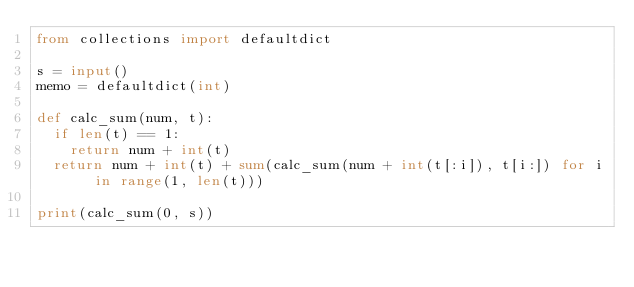<code> <loc_0><loc_0><loc_500><loc_500><_Python_>from collections import defaultdict

s = input()
memo = defaultdict(int)

def calc_sum(num, t):
  if len(t) == 1:
    return num + int(t)
  return num + int(t) + sum(calc_sum(num + int(t[:i]), t[i:]) for i in range(1, len(t)))

print(calc_sum(0, s))</code> 